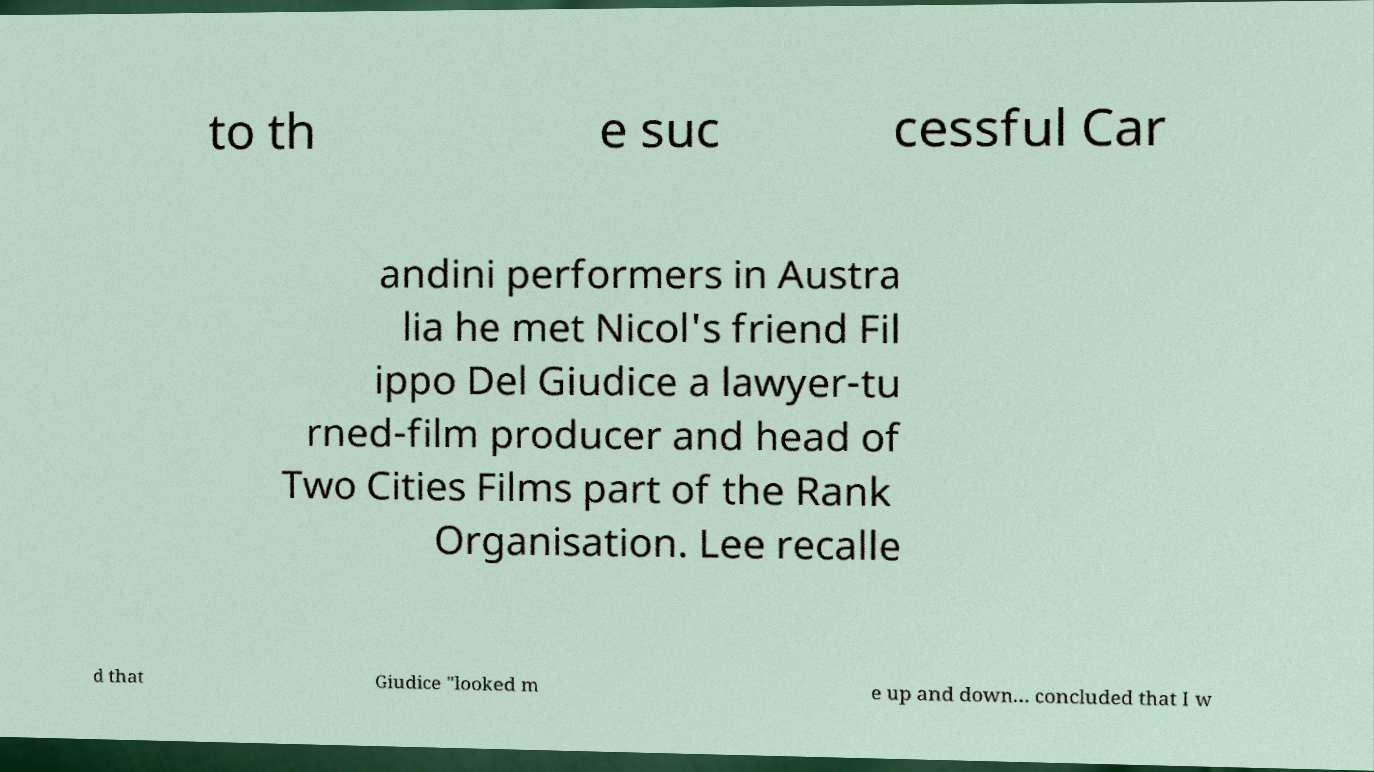What messages or text are displayed in this image? I need them in a readable, typed format. to th e suc cessful Car andini performers in Austra lia he met Nicol's friend Fil ippo Del Giudice a lawyer-tu rned-film producer and head of Two Cities Films part of the Rank Organisation. Lee recalle d that Giudice "looked m e up and down... concluded that I w 